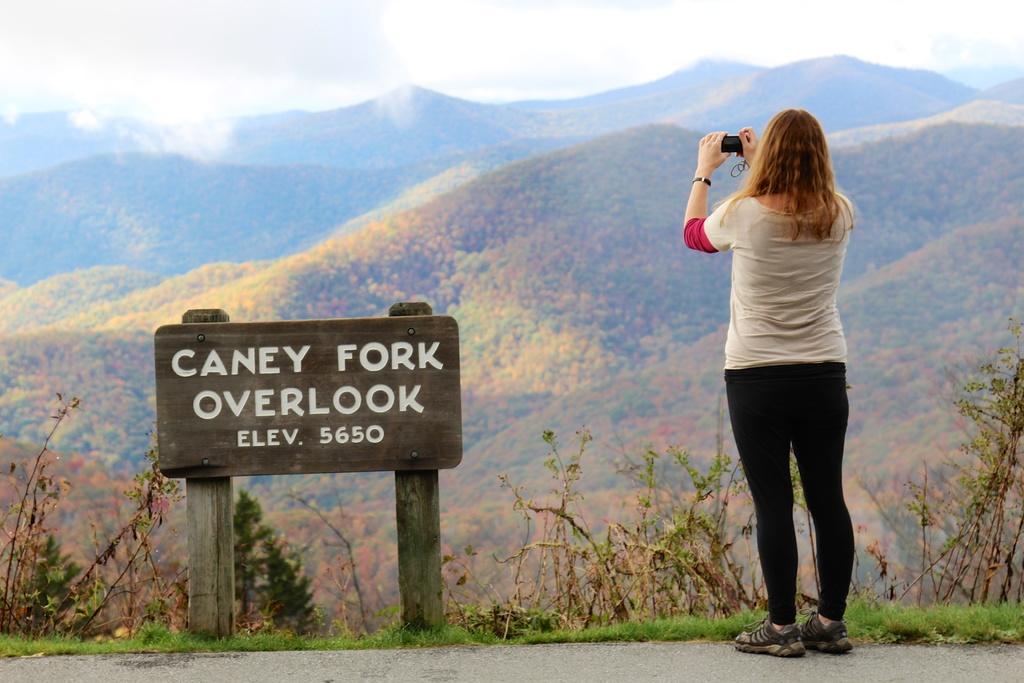Please provide a concise description of this image. In the image there is a woman standing on the road, beside her there is some wooden board and on that board some names were mentioned and the woman is capturing the beautiful scenery in front of her. 